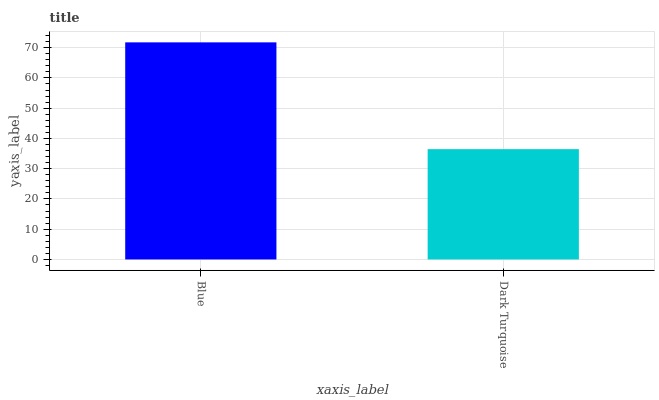Is Dark Turquoise the minimum?
Answer yes or no. Yes. Is Blue the maximum?
Answer yes or no. Yes. Is Dark Turquoise the maximum?
Answer yes or no. No. Is Blue greater than Dark Turquoise?
Answer yes or no. Yes. Is Dark Turquoise less than Blue?
Answer yes or no. Yes. Is Dark Turquoise greater than Blue?
Answer yes or no. No. Is Blue less than Dark Turquoise?
Answer yes or no. No. Is Blue the high median?
Answer yes or no. Yes. Is Dark Turquoise the low median?
Answer yes or no. Yes. Is Dark Turquoise the high median?
Answer yes or no. No. Is Blue the low median?
Answer yes or no. No. 